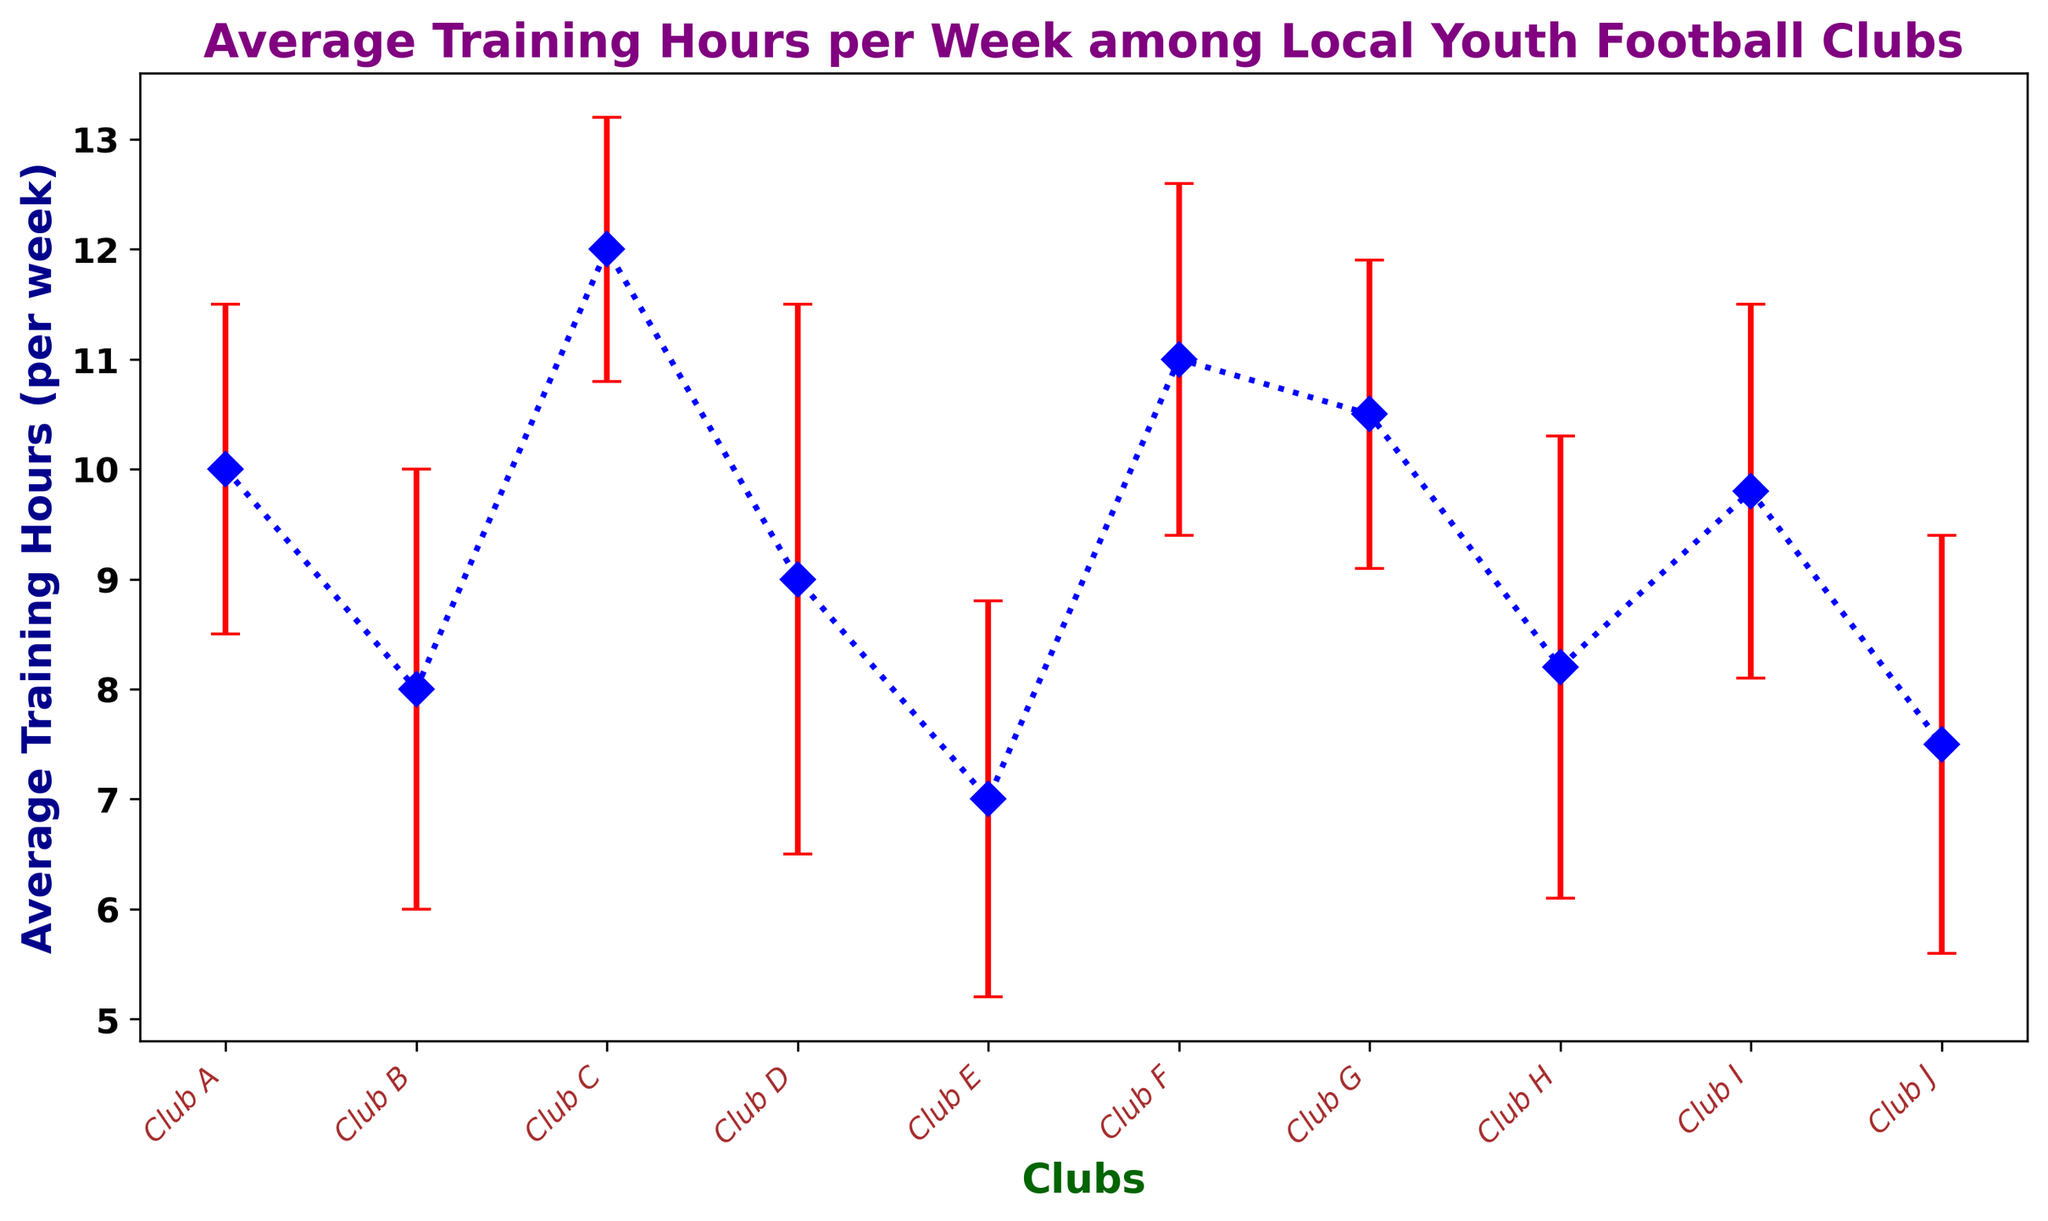Which club has the highest average training hours? From the figure, we can see that Club C has the highest average training hours at 12 hours.
Answer: Club C Which club has the largest variability in training hours? The variability is shown by the length of the error bars. Club D has the largest error bar, indicating a standard deviation of 2.5, the highest among the clubs.
Answer: Club D What is the difference in average training hours between Club A and Club B? Club A has an average of 10 hours and Club B has an average of 8 hours. The difference is 10 - 8 = 2 hours.
Answer: 2 hours Which clubs have an average training time greater than 10 hours? Clubs that have training hours greater than 10 include Club C (12 hours), Club F (11 hours), and Club G (10.5 hours).
Answer: Club C, Club F, Club G How does the training variability of Club A compare to Club F? The error bars of both clubs indicate their variability. Club A has a standard deviation of 1.5, while Club F has a standard deviation of 1.6. Club F has slightly more variability.
Answer: Club F has slightly more What is the combined average training hours of Club E and Club J? Club E has 7 hours and Club J has 7.5 hours. The combined average is (7 + 7.5)/2 = 7.25 hours.
Answer: 7.25 hours Which clubs have an average training hours within one standard deviation of Club H? Club H has an average training hour of 8.2 with a standard deviation of 2.1. The range within one standard deviation is 8.2 ± 2.1, which is from 6.1 to 10.3. Clubs within this range are Club B, Club D, Club E, Club H, Club I, and Club J.
Answer: Club B, Club D, Club E, Club H, Club I, Club J What is the average training hour difference between the club with the highest average and the club with the lowest average? Club C has the highest average at 12 hours, and Club E has the lowest at 7 hours. The difference is 12 - 7 = 5 hours.
Answer: 5 hours What is the total number of clubs that train on average fewer than 9 hours per week? Clubs with average training hours fewer than 9 include Club B (8 hours), Club E (7 hours), Club H (8.2 hours), and Club J (7.5 hours). There are 4 such clubs.
Answer: 4 clubs Which club has average training hours equal to the overall average of the dataset? To find the overall average, sum the average hours of all clubs and divide by 10 (number of clubs). The sum is 10 + 8 + 12 + 9 + 7 + 11 + 10.5 + 8.2 + 9.8 + 7.5 = 93. The overall average is 93/10 = 9.3 hours. None of the clubs have an average training hour of exactly 9.3 hours.
Answer: None 